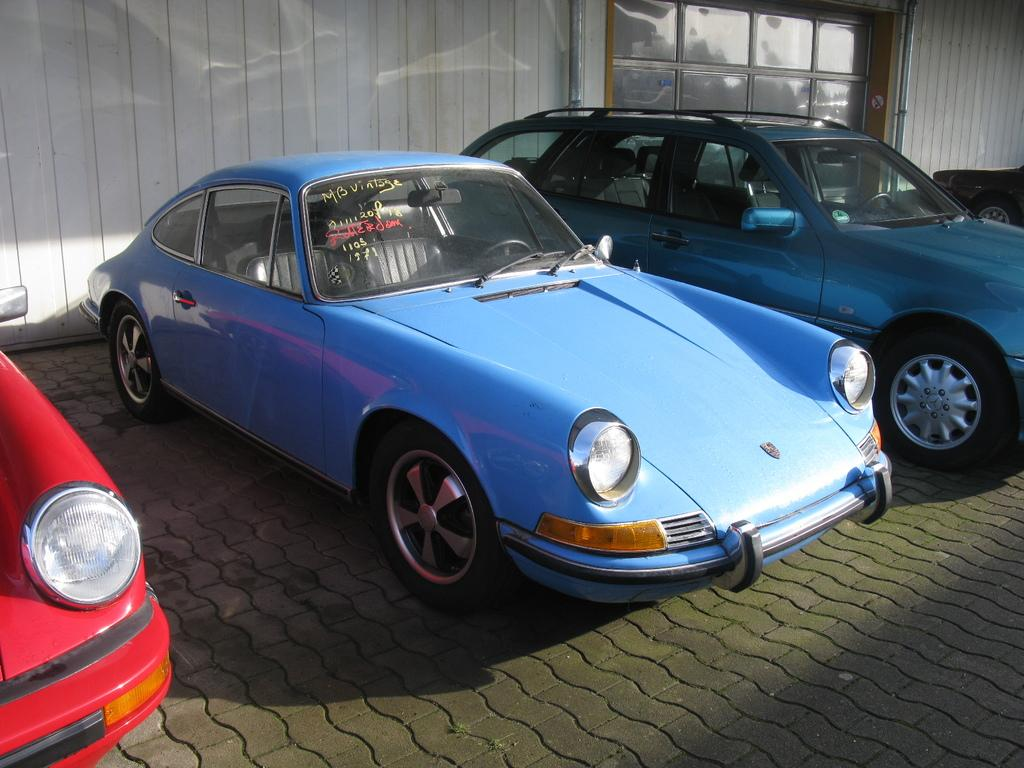What types of vehicles can be seen on the ground in the image? There are vehicles on the ground in the image, but the specific types cannot be determined from the provided facts. What is located in the background of the image? There is an object and a wall in the background of the image. Can you describe the wall in the background? The facts do not provide enough information to describe the wall in the background. How many fish can be seen swimming near the coast in the image? There is no coast or fish present in the image; it features vehicles on the ground and objects in the background. 